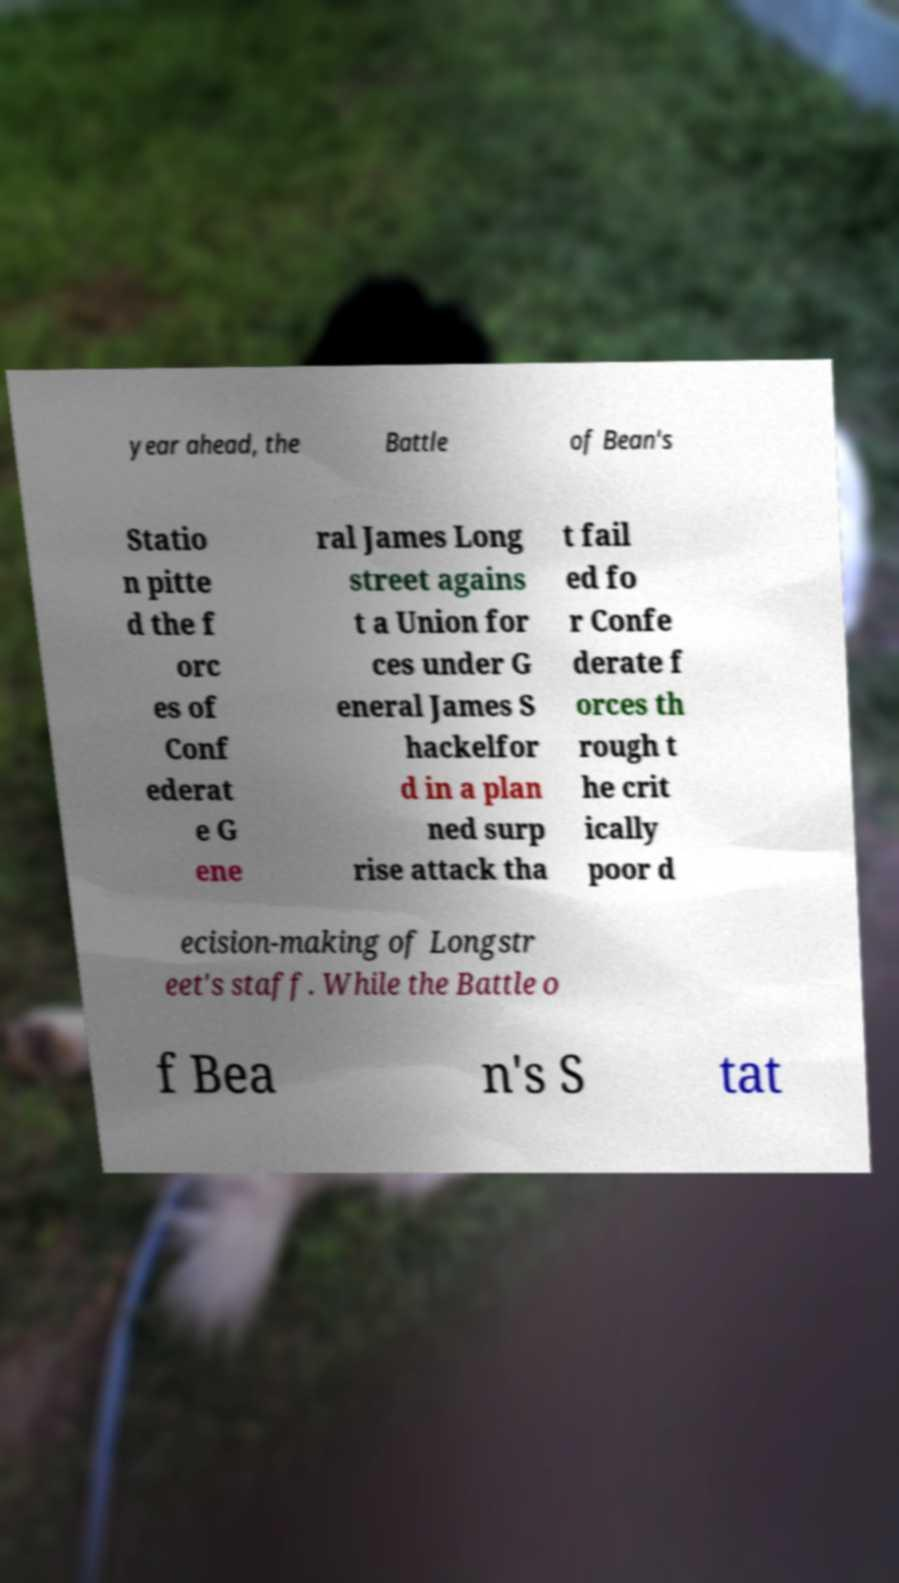Can you accurately transcribe the text from the provided image for me? year ahead, the Battle of Bean's Statio n pitte d the f orc es of Conf ederat e G ene ral James Long street agains t a Union for ces under G eneral James S hackelfor d in a plan ned surp rise attack tha t fail ed fo r Confe derate f orces th rough t he crit ically poor d ecision-making of Longstr eet's staff. While the Battle o f Bea n's S tat 